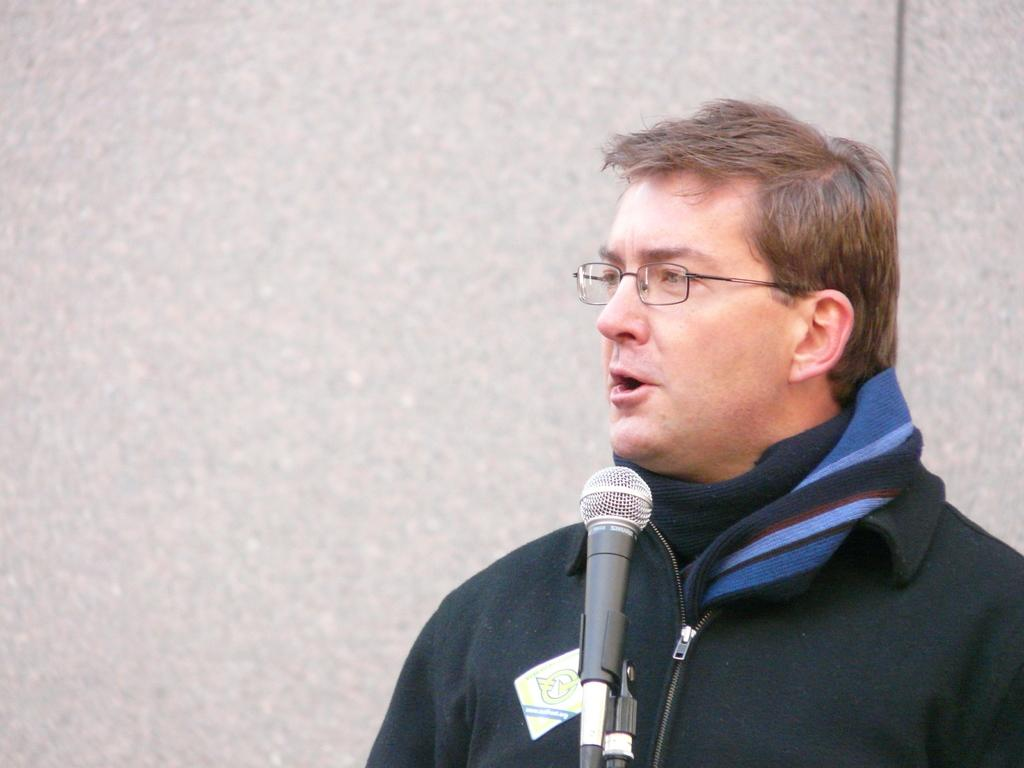Who is in the image? There is a person in the image. What is the person wearing? The person is wearing a black jacket. What is the person doing in the image? The person is speaking in front of a microphone. How many cent balls are on the table in the image? There are no cent balls present in the image. 